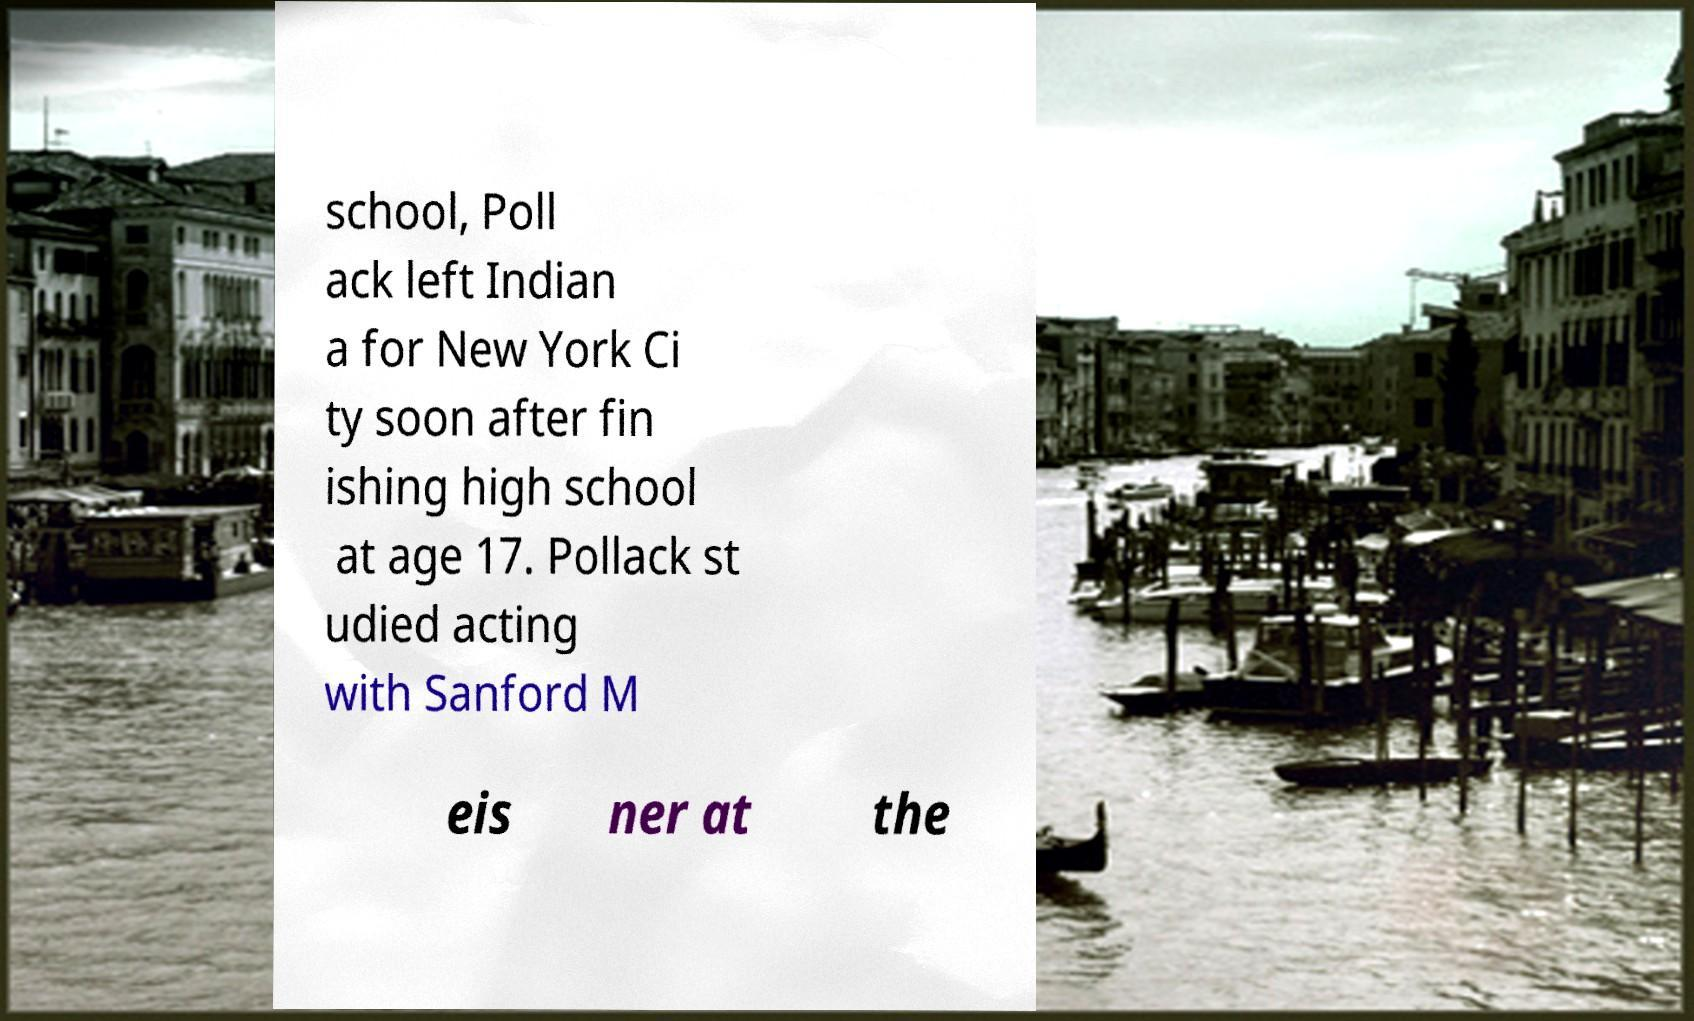I need the written content from this picture converted into text. Can you do that? school, Poll ack left Indian a for New York Ci ty soon after fin ishing high school at age 17. Pollack st udied acting with Sanford M eis ner at the 